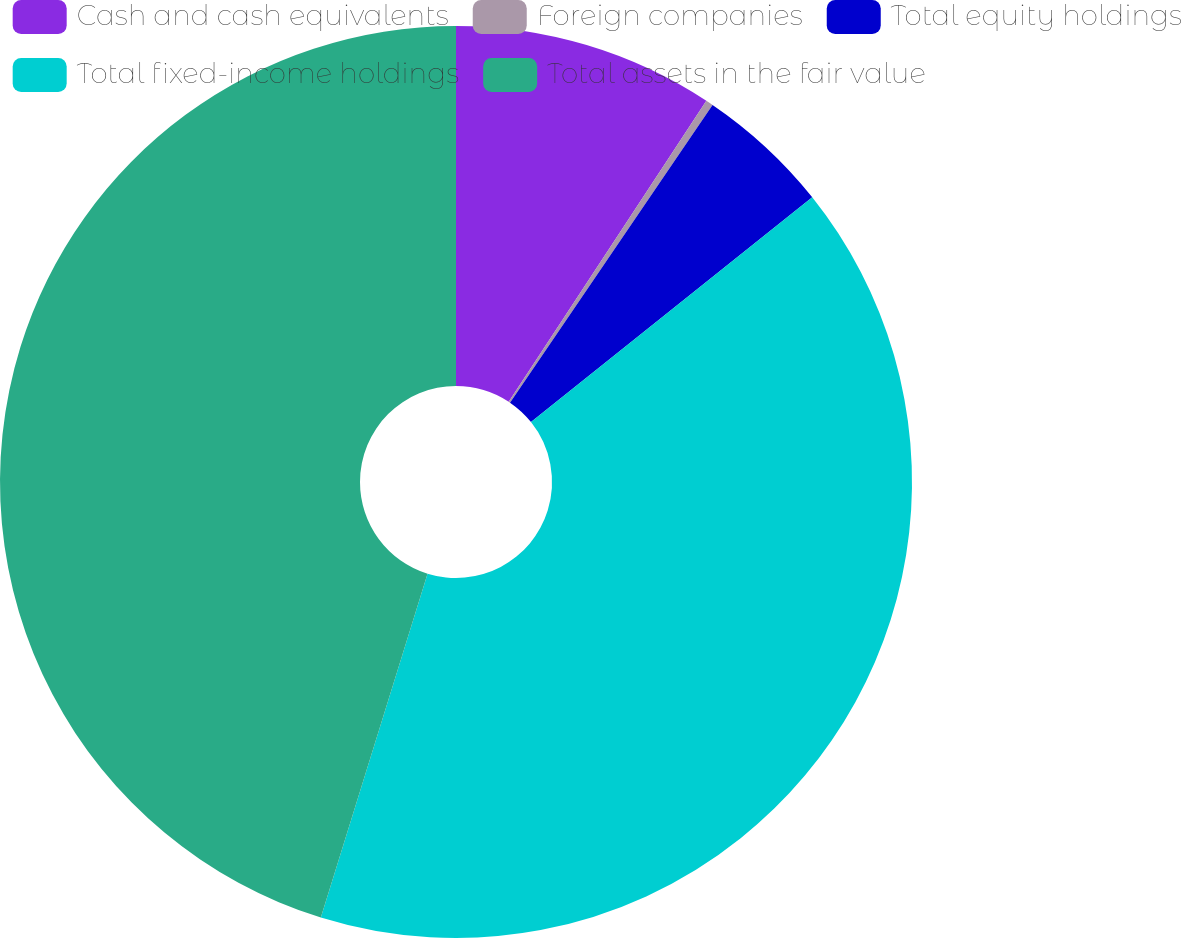Convert chart to OTSL. <chart><loc_0><loc_0><loc_500><loc_500><pie_chart><fcel>Cash and cash equivalents<fcel>Foreign companies<fcel>Total equity holdings<fcel>Total fixed-income holdings<fcel>Total assets in the fair value<nl><fcel>9.25%<fcel>0.26%<fcel>4.76%<fcel>40.52%<fcel>45.21%<nl></chart> 